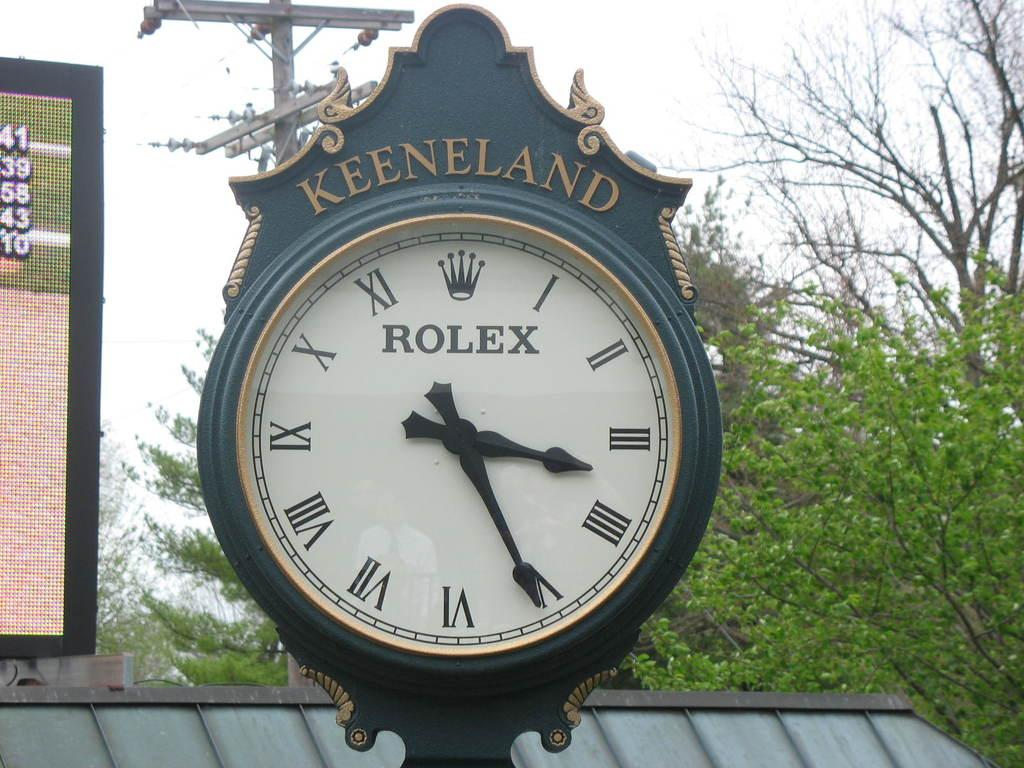<image>
Provide a brief description of the given image. Large clock with the word ROLEX on the face and the word KEENELAND on the top. 